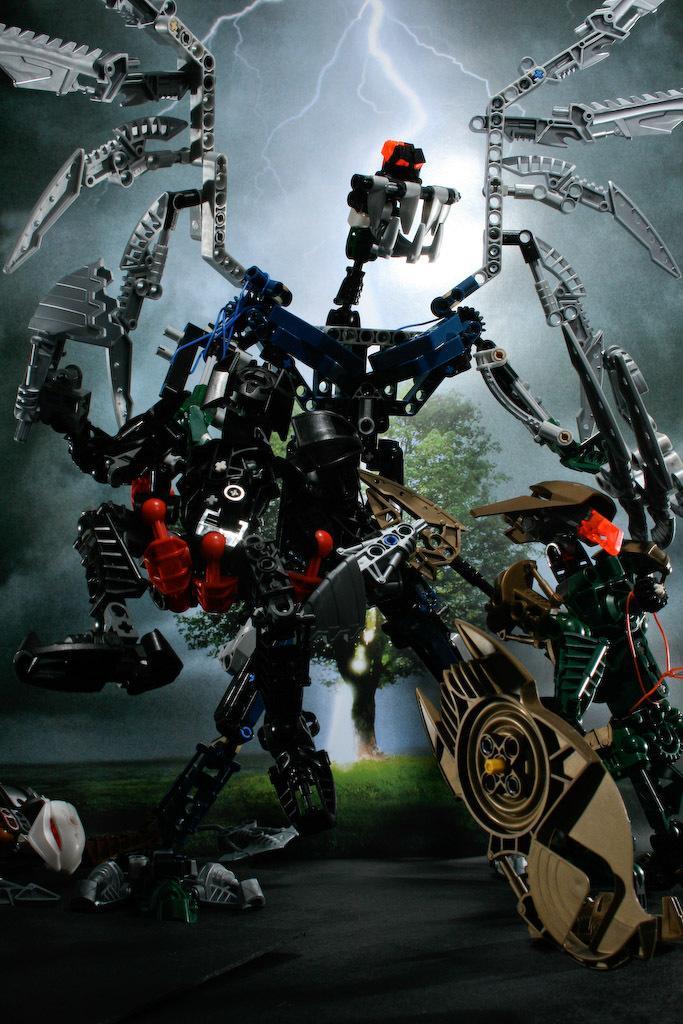In one or two sentences, can you explain what this image depicts? In the middle of this image, there is a robot on the road. In the background, there is grass and a tree on the ground and there are clouds, a moon and a thunder in the sky. 